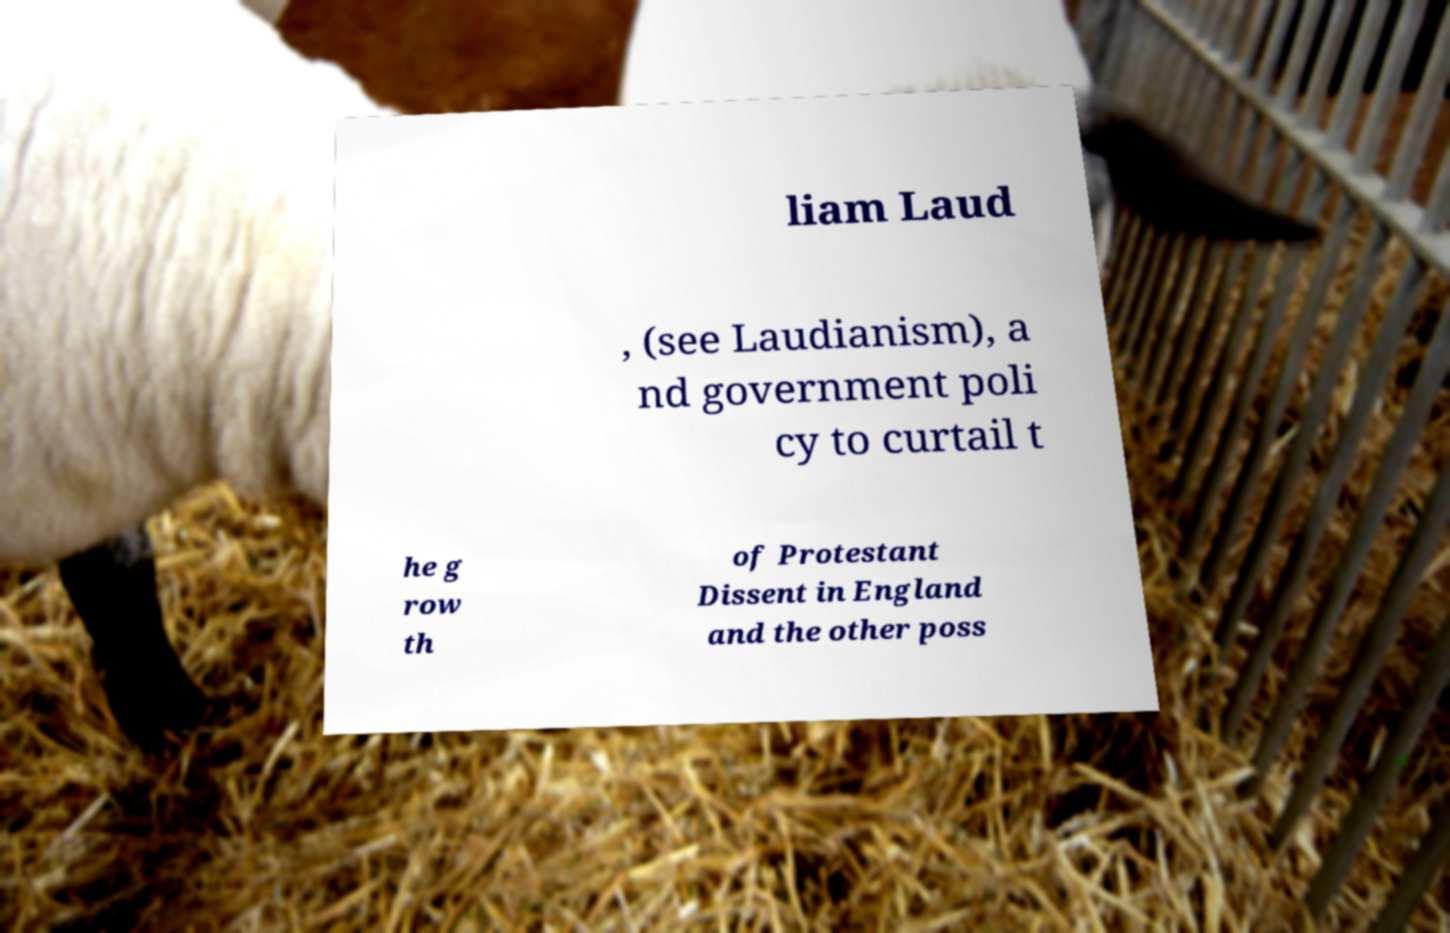Could you extract and type out the text from this image? liam Laud , (see Laudianism), a nd government poli cy to curtail t he g row th of Protestant Dissent in England and the other poss 